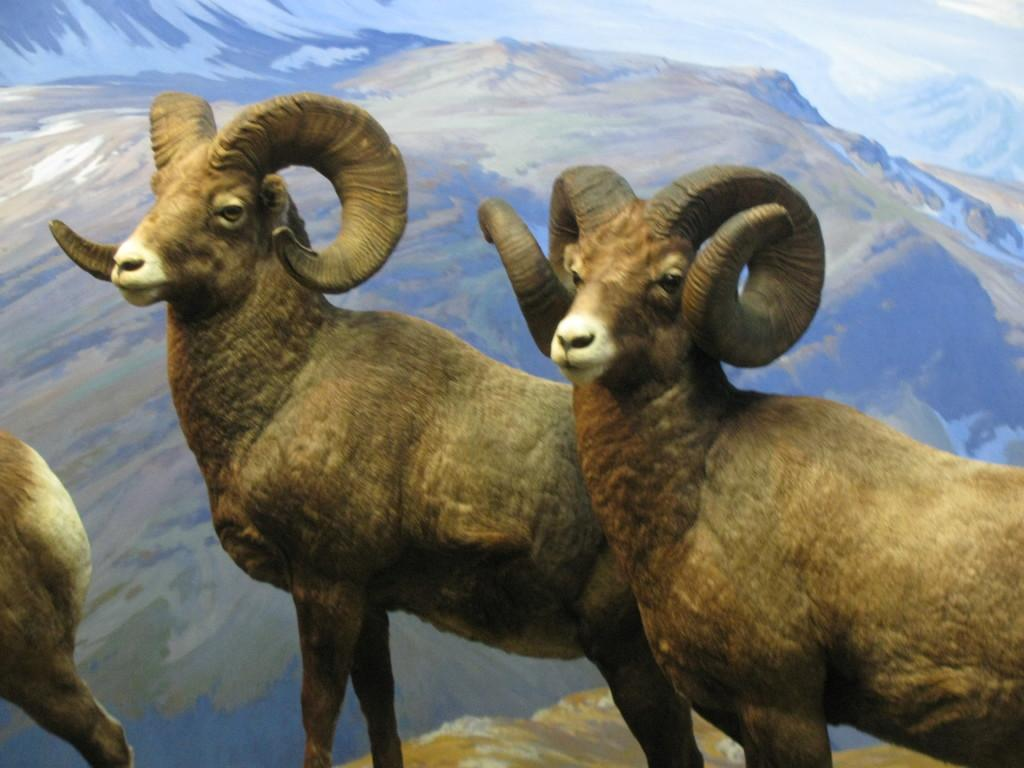What type of animal is present in the image? There is a sheep in the image. What natural feature can be seen in the background of the image? Mountains are visible in the image. What is the texture of the ground in the image? There is ice in the image, suggesting a cold or snowy environment. What type of park can be seen in the image? There is no park present in the image; it features a sheep and mountains with ice. 